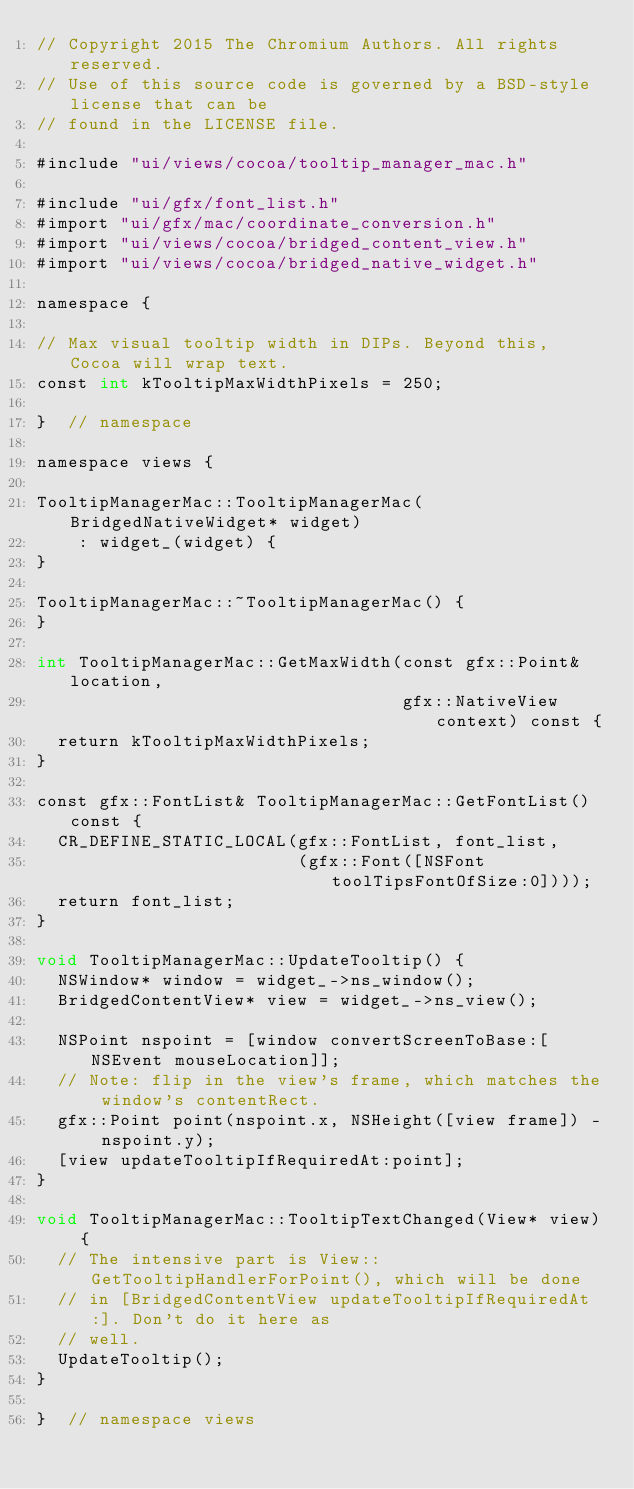Convert code to text. <code><loc_0><loc_0><loc_500><loc_500><_ObjectiveC_>// Copyright 2015 The Chromium Authors. All rights reserved.
// Use of this source code is governed by a BSD-style license that can be
// found in the LICENSE file.

#include "ui/views/cocoa/tooltip_manager_mac.h"

#include "ui/gfx/font_list.h"
#import "ui/gfx/mac/coordinate_conversion.h"
#import "ui/views/cocoa/bridged_content_view.h"
#import "ui/views/cocoa/bridged_native_widget.h"

namespace {

// Max visual tooltip width in DIPs. Beyond this, Cocoa will wrap text.
const int kTooltipMaxWidthPixels = 250;

}  // namespace

namespace views {

TooltipManagerMac::TooltipManagerMac(BridgedNativeWidget* widget)
    : widget_(widget) {
}

TooltipManagerMac::~TooltipManagerMac() {
}

int TooltipManagerMac::GetMaxWidth(const gfx::Point& location,
                                   gfx::NativeView context) const {
  return kTooltipMaxWidthPixels;
}

const gfx::FontList& TooltipManagerMac::GetFontList() const {
  CR_DEFINE_STATIC_LOCAL(gfx::FontList, font_list,
                         (gfx::Font([NSFont toolTipsFontOfSize:0])));
  return font_list;
}

void TooltipManagerMac::UpdateTooltip() {
  NSWindow* window = widget_->ns_window();
  BridgedContentView* view = widget_->ns_view();

  NSPoint nspoint = [window convertScreenToBase:[NSEvent mouseLocation]];
  // Note: flip in the view's frame, which matches the window's contentRect.
  gfx::Point point(nspoint.x, NSHeight([view frame]) - nspoint.y);
  [view updateTooltipIfRequiredAt:point];
}

void TooltipManagerMac::TooltipTextChanged(View* view) {
  // The intensive part is View::GetTooltipHandlerForPoint(), which will be done
  // in [BridgedContentView updateTooltipIfRequiredAt:]. Don't do it here as
  // well.
  UpdateTooltip();
}

}  // namespace views
</code> 